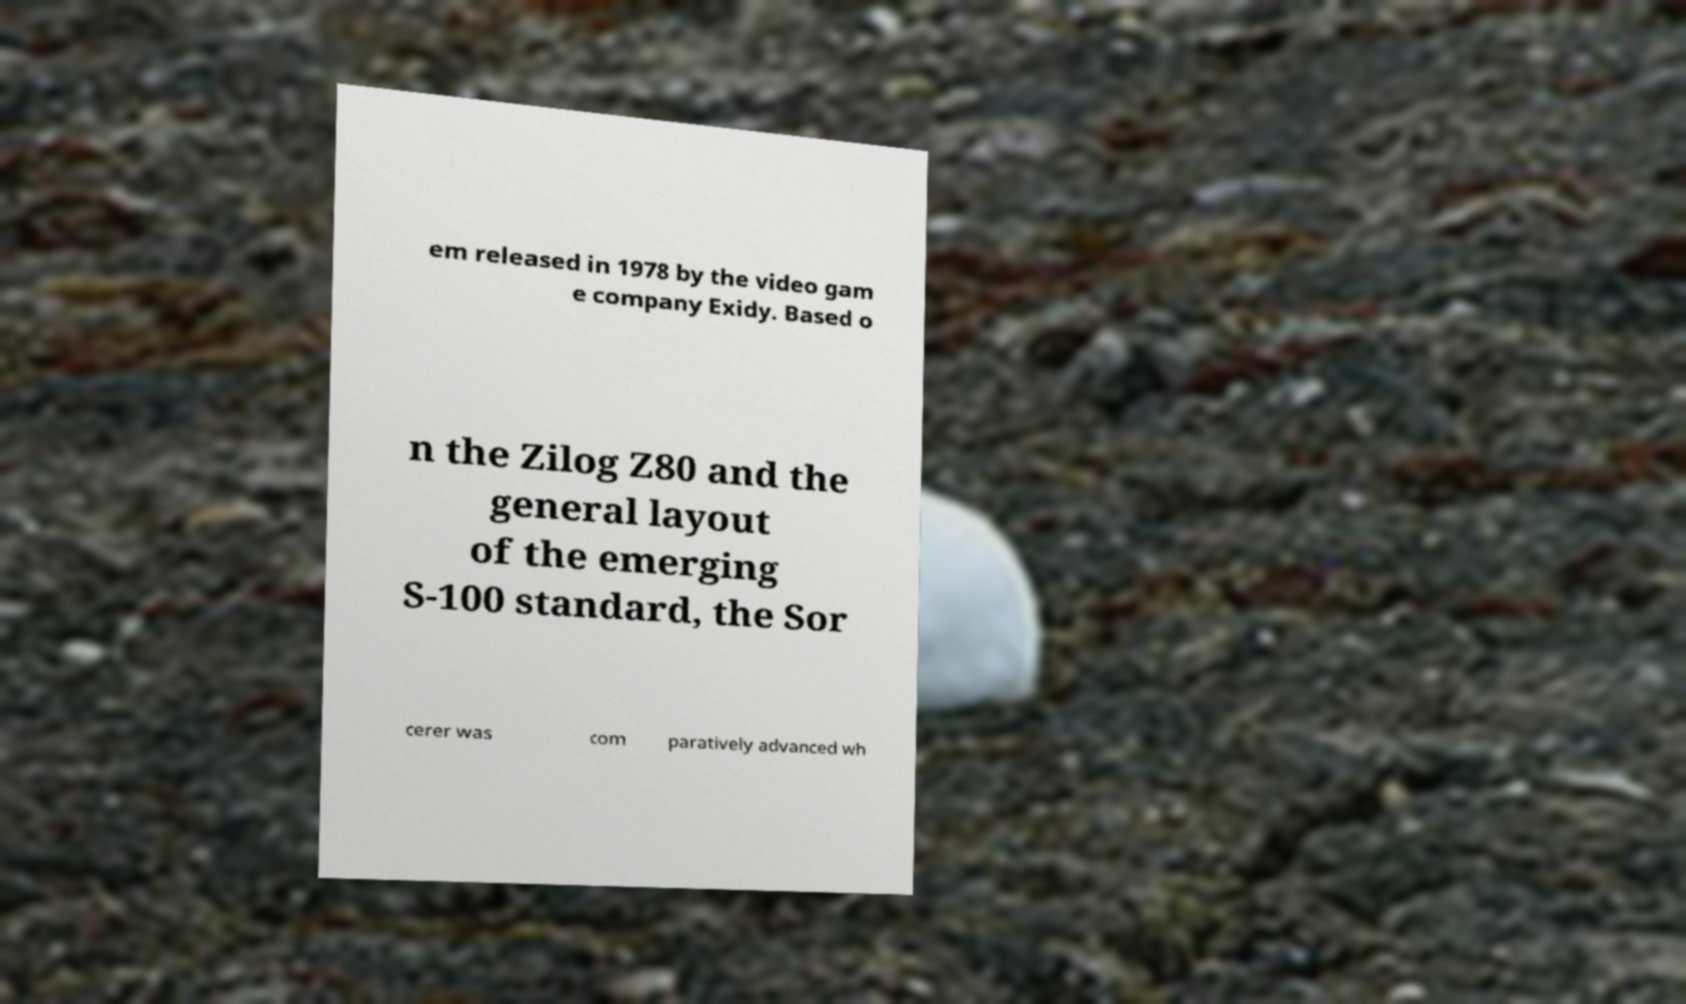What messages or text are displayed in this image? I need them in a readable, typed format. em released in 1978 by the video gam e company Exidy. Based o n the Zilog Z80 and the general layout of the emerging S-100 standard, the Sor cerer was com paratively advanced wh 